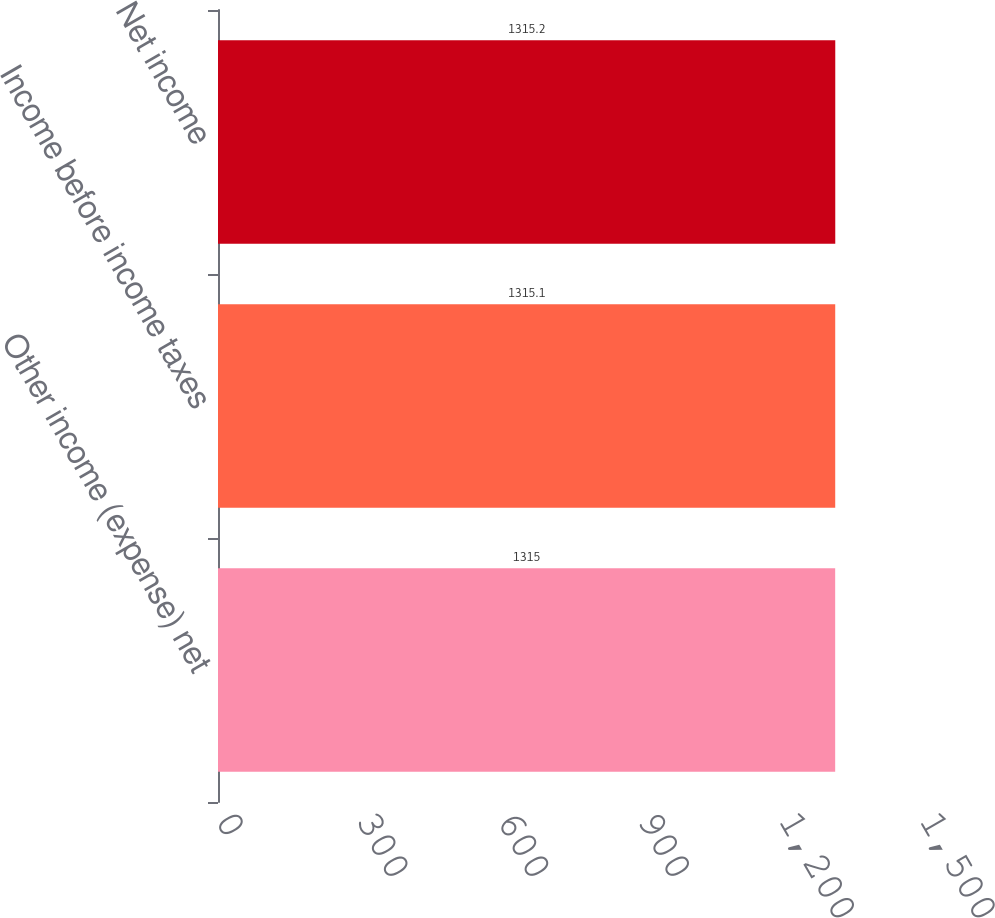Convert chart to OTSL. <chart><loc_0><loc_0><loc_500><loc_500><bar_chart><fcel>Other income (expense) net<fcel>Income before income taxes<fcel>Net income<nl><fcel>1315<fcel>1315.1<fcel>1315.2<nl></chart> 